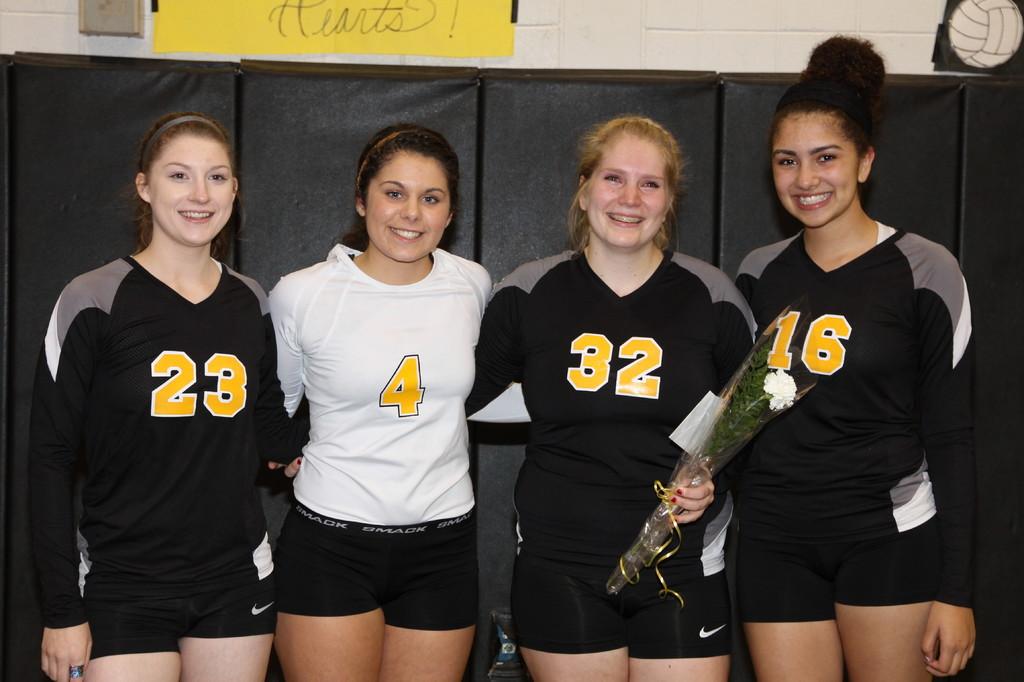The girl in white is representing what number?
Your response must be concise. 4. What number is on the girls on the left?
Make the answer very short. 23. 